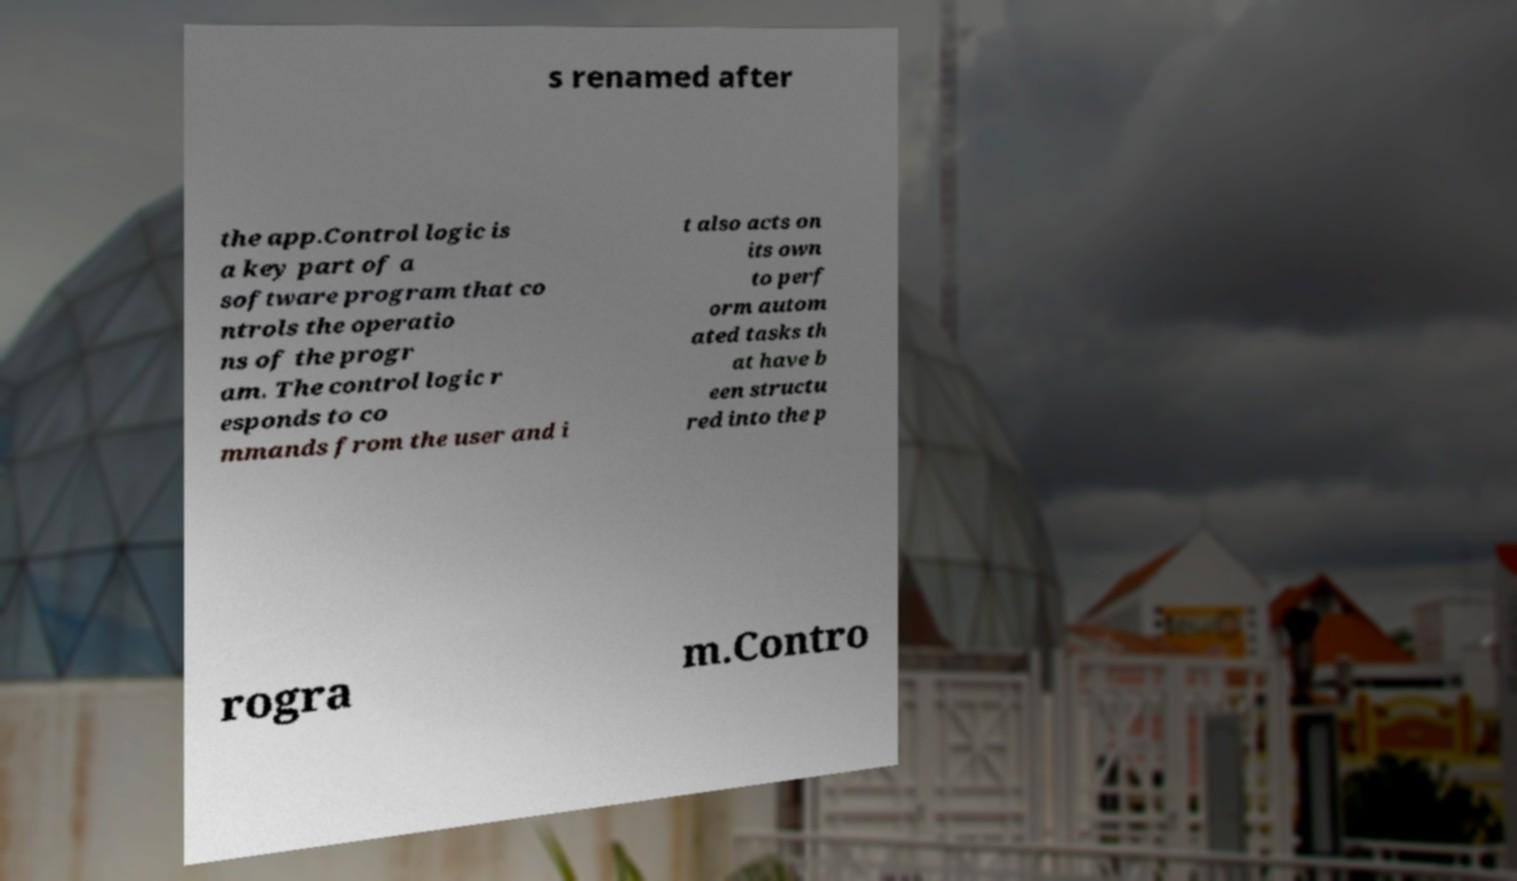What messages or text are displayed in this image? I need them in a readable, typed format. s renamed after the app.Control logic is a key part of a software program that co ntrols the operatio ns of the progr am. The control logic r esponds to co mmands from the user and i t also acts on its own to perf orm autom ated tasks th at have b een structu red into the p rogra m.Contro 